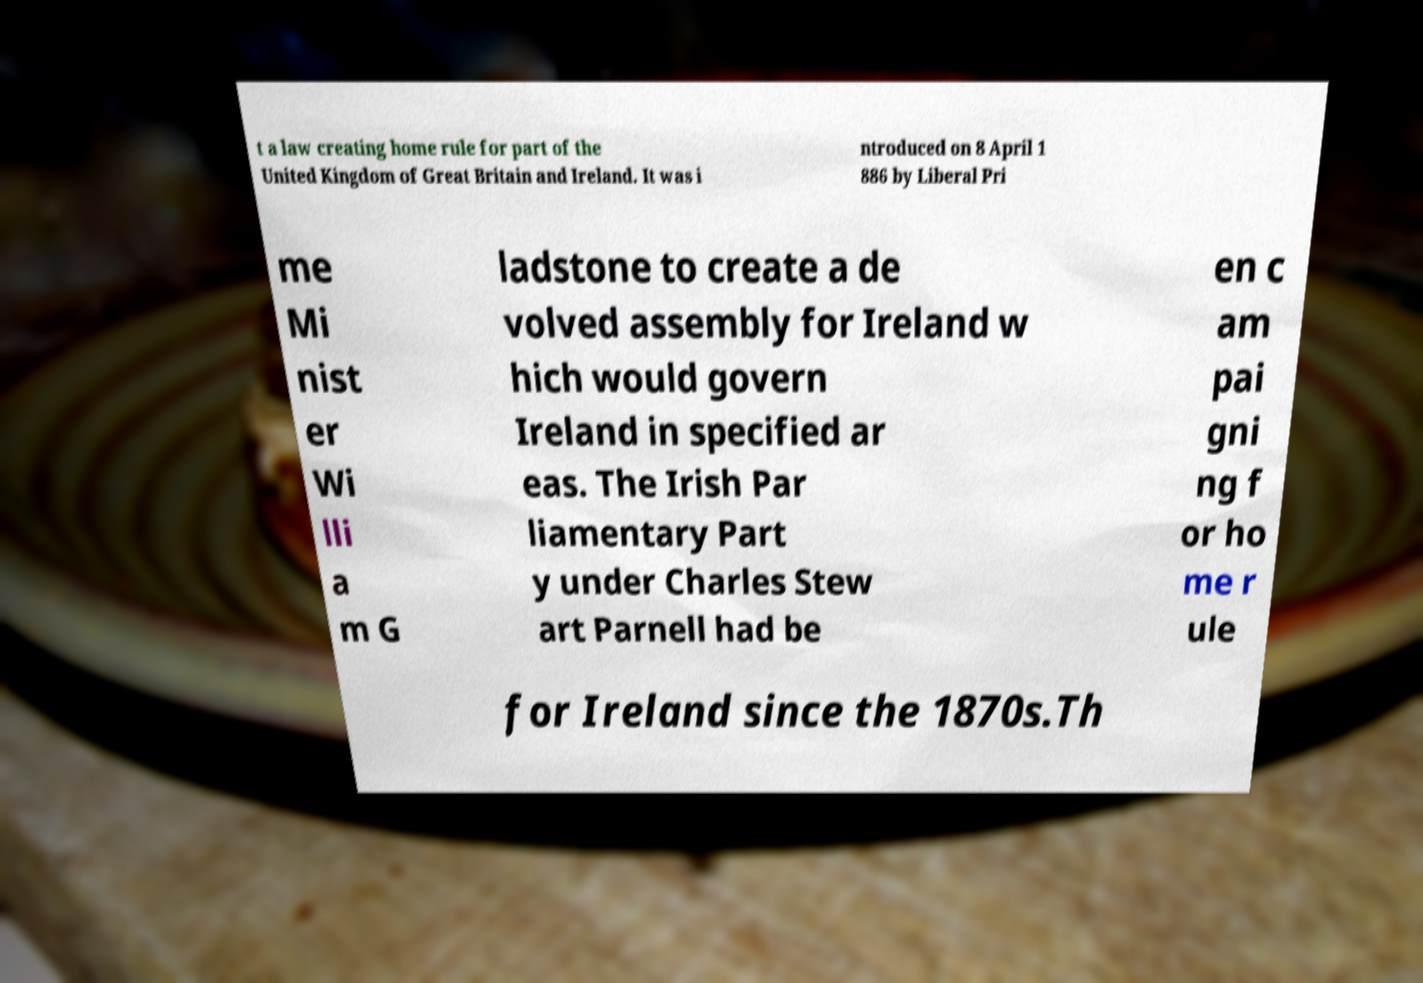Please identify and transcribe the text found in this image. t a law creating home rule for part of the United Kingdom of Great Britain and Ireland. It was i ntroduced on 8 April 1 886 by Liberal Pri me Mi nist er Wi lli a m G ladstone to create a de volved assembly for Ireland w hich would govern Ireland in specified ar eas. The Irish Par liamentary Part y under Charles Stew art Parnell had be en c am pai gni ng f or ho me r ule for Ireland since the 1870s.Th 